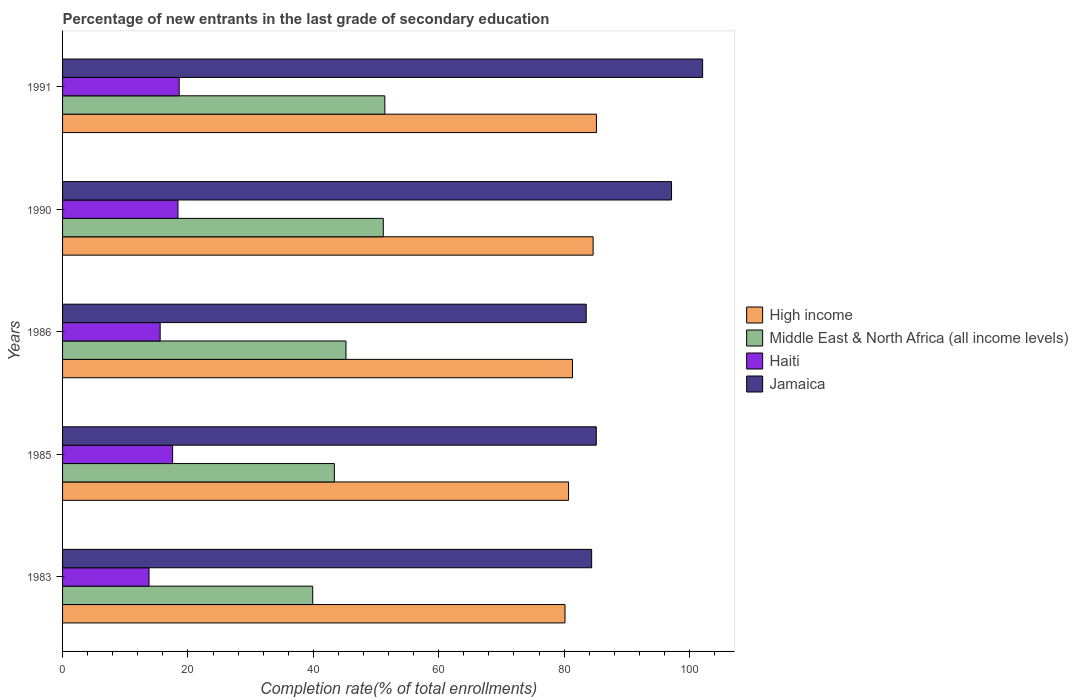How many different coloured bars are there?
Provide a succinct answer. 4. How many groups of bars are there?
Provide a short and direct response. 5. Are the number of bars on each tick of the Y-axis equal?
Keep it short and to the point. Yes. How many bars are there on the 5th tick from the top?
Provide a succinct answer. 4. How many bars are there on the 4th tick from the bottom?
Provide a succinct answer. 4. What is the label of the 4th group of bars from the top?
Keep it short and to the point. 1985. What is the percentage of new entrants in Jamaica in 1985?
Offer a very short reply. 85.13. Across all years, what is the maximum percentage of new entrants in Haiti?
Provide a succinct answer. 18.6. Across all years, what is the minimum percentage of new entrants in Jamaica?
Provide a succinct answer. 83.53. In which year was the percentage of new entrants in High income minimum?
Provide a succinct answer. 1983. What is the total percentage of new entrants in High income in the graph?
Provide a succinct answer. 411.98. What is the difference between the percentage of new entrants in Jamaica in 1985 and that in 1991?
Your answer should be compact. -16.96. What is the difference between the percentage of new entrants in Jamaica in 1985 and the percentage of new entrants in Middle East & North Africa (all income levels) in 1986?
Offer a terse response. 39.93. What is the average percentage of new entrants in High income per year?
Give a very brief answer. 82.4. In the year 1991, what is the difference between the percentage of new entrants in High income and percentage of new entrants in Jamaica?
Give a very brief answer. -16.94. What is the ratio of the percentage of new entrants in Jamaica in 1986 to that in 1991?
Make the answer very short. 0.82. Is the percentage of new entrants in Middle East & North Africa (all income levels) in 1986 less than that in 1990?
Offer a terse response. Yes. Is the difference between the percentage of new entrants in High income in 1990 and 1991 greater than the difference between the percentage of new entrants in Jamaica in 1990 and 1991?
Your response must be concise. Yes. What is the difference between the highest and the second highest percentage of new entrants in Jamaica?
Keep it short and to the point. 4.96. What is the difference between the highest and the lowest percentage of new entrants in Jamaica?
Give a very brief answer. 18.57. Is the sum of the percentage of new entrants in High income in 1985 and 1991 greater than the maximum percentage of new entrants in Middle East & North Africa (all income levels) across all years?
Your answer should be compact. Yes. Is it the case that in every year, the sum of the percentage of new entrants in Middle East & North Africa (all income levels) and percentage of new entrants in Haiti is greater than the sum of percentage of new entrants in High income and percentage of new entrants in Jamaica?
Your response must be concise. No. What does the 3rd bar from the top in 1986 represents?
Make the answer very short. Middle East & North Africa (all income levels). What does the 3rd bar from the bottom in 1990 represents?
Make the answer very short. Haiti. How many bars are there?
Your response must be concise. 20. How many years are there in the graph?
Keep it short and to the point. 5. What is the difference between two consecutive major ticks on the X-axis?
Make the answer very short. 20. Are the values on the major ticks of X-axis written in scientific E-notation?
Make the answer very short. No. How many legend labels are there?
Your answer should be compact. 4. How are the legend labels stacked?
Make the answer very short. Vertical. What is the title of the graph?
Keep it short and to the point. Percentage of new entrants in the last grade of secondary education. Does "Andorra" appear as one of the legend labels in the graph?
Make the answer very short. No. What is the label or title of the X-axis?
Your answer should be compact. Completion rate(% of total enrollments). What is the label or title of the Y-axis?
Provide a short and direct response. Years. What is the Completion rate(% of total enrollments) of High income in 1983?
Provide a succinct answer. 80.15. What is the Completion rate(% of total enrollments) of Middle East & North Africa (all income levels) in 1983?
Offer a very short reply. 39.9. What is the Completion rate(% of total enrollments) in Haiti in 1983?
Keep it short and to the point. 13.79. What is the Completion rate(% of total enrollments) in Jamaica in 1983?
Provide a succinct answer. 84.4. What is the Completion rate(% of total enrollments) in High income in 1985?
Ensure brevity in your answer.  80.71. What is the Completion rate(% of total enrollments) in Middle East & North Africa (all income levels) in 1985?
Provide a succinct answer. 43.35. What is the Completion rate(% of total enrollments) of Haiti in 1985?
Your answer should be very brief. 17.55. What is the Completion rate(% of total enrollments) in Jamaica in 1985?
Your answer should be compact. 85.13. What is the Completion rate(% of total enrollments) of High income in 1986?
Provide a succinct answer. 81.34. What is the Completion rate(% of total enrollments) of Middle East & North Africa (all income levels) in 1986?
Offer a very short reply. 45.21. What is the Completion rate(% of total enrollments) of Haiti in 1986?
Give a very brief answer. 15.57. What is the Completion rate(% of total enrollments) in Jamaica in 1986?
Your answer should be compact. 83.53. What is the Completion rate(% of total enrollments) in High income in 1990?
Make the answer very short. 84.63. What is the Completion rate(% of total enrollments) of Middle East & North Africa (all income levels) in 1990?
Keep it short and to the point. 51.16. What is the Completion rate(% of total enrollments) in Haiti in 1990?
Your response must be concise. 18.41. What is the Completion rate(% of total enrollments) of Jamaica in 1990?
Give a very brief answer. 97.14. What is the Completion rate(% of total enrollments) of High income in 1991?
Your answer should be very brief. 85.16. What is the Completion rate(% of total enrollments) in Middle East & North Africa (all income levels) in 1991?
Provide a succinct answer. 51.41. What is the Completion rate(% of total enrollments) in Haiti in 1991?
Your answer should be compact. 18.6. What is the Completion rate(% of total enrollments) of Jamaica in 1991?
Make the answer very short. 102.1. Across all years, what is the maximum Completion rate(% of total enrollments) of High income?
Give a very brief answer. 85.16. Across all years, what is the maximum Completion rate(% of total enrollments) of Middle East & North Africa (all income levels)?
Your response must be concise. 51.41. Across all years, what is the maximum Completion rate(% of total enrollments) of Haiti?
Your response must be concise. 18.6. Across all years, what is the maximum Completion rate(% of total enrollments) of Jamaica?
Provide a short and direct response. 102.1. Across all years, what is the minimum Completion rate(% of total enrollments) in High income?
Make the answer very short. 80.15. Across all years, what is the minimum Completion rate(% of total enrollments) of Middle East & North Africa (all income levels)?
Offer a terse response. 39.9. Across all years, what is the minimum Completion rate(% of total enrollments) in Haiti?
Your answer should be very brief. 13.79. Across all years, what is the minimum Completion rate(% of total enrollments) of Jamaica?
Your answer should be very brief. 83.53. What is the total Completion rate(% of total enrollments) in High income in the graph?
Your response must be concise. 411.98. What is the total Completion rate(% of total enrollments) in Middle East & North Africa (all income levels) in the graph?
Provide a succinct answer. 231.02. What is the total Completion rate(% of total enrollments) of Haiti in the graph?
Give a very brief answer. 83.92. What is the total Completion rate(% of total enrollments) of Jamaica in the graph?
Your answer should be compact. 452.29. What is the difference between the Completion rate(% of total enrollments) of High income in 1983 and that in 1985?
Provide a succinct answer. -0.56. What is the difference between the Completion rate(% of total enrollments) of Middle East & North Africa (all income levels) in 1983 and that in 1985?
Ensure brevity in your answer.  -3.45. What is the difference between the Completion rate(% of total enrollments) of Haiti in 1983 and that in 1985?
Make the answer very short. -3.76. What is the difference between the Completion rate(% of total enrollments) in Jamaica in 1983 and that in 1985?
Keep it short and to the point. -0.74. What is the difference between the Completion rate(% of total enrollments) of High income in 1983 and that in 1986?
Provide a succinct answer. -1.19. What is the difference between the Completion rate(% of total enrollments) in Middle East & North Africa (all income levels) in 1983 and that in 1986?
Offer a terse response. -5.31. What is the difference between the Completion rate(% of total enrollments) in Haiti in 1983 and that in 1986?
Ensure brevity in your answer.  -1.78. What is the difference between the Completion rate(% of total enrollments) in Jamaica in 1983 and that in 1986?
Offer a terse response. 0.87. What is the difference between the Completion rate(% of total enrollments) of High income in 1983 and that in 1990?
Your answer should be very brief. -4.48. What is the difference between the Completion rate(% of total enrollments) in Middle East & North Africa (all income levels) in 1983 and that in 1990?
Your response must be concise. -11.25. What is the difference between the Completion rate(% of total enrollments) of Haiti in 1983 and that in 1990?
Make the answer very short. -4.62. What is the difference between the Completion rate(% of total enrollments) of Jamaica in 1983 and that in 1990?
Keep it short and to the point. -12.74. What is the difference between the Completion rate(% of total enrollments) of High income in 1983 and that in 1991?
Keep it short and to the point. -5.01. What is the difference between the Completion rate(% of total enrollments) of Middle East & North Africa (all income levels) in 1983 and that in 1991?
Your answer should be very brief. -11.5. What is the difference between the Completion rate(% of total enrollments) in Haiti in 1983 and that in 1991?
Keep it short and to the point. -4.81. What is the difference between the Completion rate(% of total enrollments) in Jamaica in 1983 and that in 1991?
Your response must be concise. -17.7. What is the difference between the Completion rate(% of total enrollments) in High income in 1985 and that in 1986?
Your response must be concise. -0.63. What is the difference between the Completion rate(% of total enrollments) in Middle East & North Africa (all income levels) in 1985 and that in 1986?
Make the answer very short. -1.86. What is the difference between the Completion rate(% of total enrollments) of Haiti in 1985 and that in 1986?
Ensure brevity in your answer.  1.98. What is the difference between the Completion rate(% of total enrollments) of Jamaica in 1985 and that in 1986?
Give a very brief answer. 1.61. What is the difference between the Completion rate(% of total enrollments) in High income in 1985 and that in 1990?
Offer a terse response. -3.92. What is the difference between the Completion rate(% of total enrollments) of Middle East & North Africa (all income levels) in 1985 and that in 1990?
Provide a short and direct response. -7.81. What is the difference between the Completion rate(% of total enrollments) in Haiti in 1985 and that in 1990?
Give a very brief answer. -0.86. What is the difference between the Completion rate(% of total enrollments) in Jamaica in 1985 and that in 1990?
Provide a succinct answer. -12. What is the difference between the Completion rate(% of total enrollments) of High income in 1985 and that in 1991?
Your response must be concise. -4.44. What is the difference between the Completion rate(% of total enrollments) of Middle East & North Africa (all income levels) in 1985 and that in 1991?
Offer a very short reply. -8.06. What is the difference between the Completion rate(% of total enrollments) of Haiti in 1985 and that in 1991?
Provide a short and direct response. -1.05. What is the difference between the Completion rate(% of total enrollments) in Jamaica in 1985 and that in 1991?
Make the answer very short. -16.96. What is the difference between the Completion rate(% of total enrollments) of High income in 1986 and that in 1990?
Offer a very short reply. -3.29. What is the difference between the Completion rate(% of total enrollments) in Middle East & North Africa (all income levels) in 1986 and that in 1990?
Your response must be concise. -5.95. What is the difference between the Completion rate(% of total enrollments) in Haiti in 1986 and that in 1990?
Your response must be concise. -2.84. What is the difference between the Completion rate(% of total enrollments) in Jamaica in 1986 and that in 1990?
Provide a succinct answer. -13.61. What is the difference between the Completion rate(% of total enrollments) of High income in 1986 and that in 1991?
Your answer should be compact. -3.81. What is the difference between the Completion rate(% of total enrollments) in Middle East & North Africa (all income levels) in 1986 and that in 1991?
Provide a short and direct response. -6.2. What is the difference between the Completion rate(% of total enrollments) of Haiti in 1986 and that in 1991?
Your answer should be very brief. -3.03. What is the difference between the Completion rate(% of total enrollments) in Jamaica in 1986 and that in 1991?
Ensure brevity in your answer.  -18.57. What is the difference between the Completion rate(% of total enrollments) in High income in 1990 and that in 1991?
Ensure brevity in your answer.  -0.53. What is the difference between the Completion rate(% of total enrollments) of Middle East & North Africa (all income levels) in 1990 and that in 1991?
Your answer should be compact. -0.25. What is the difference between the Completion rate(% of total enrollments) in Haiti in 1990 and that in 1991?
Provide a succinct answer. -0.19. What is the difference between the Completion rate(% of total enrollments) in Jamaica in 1990 and that in 1991?
Your response must be concise. -4.96. What is the difference between the Completion rate(% of total enrollments) of High income in 1983 and the Completion rate(% of total enrollments) of Middle East & North Africa (all income levels) in 1985?
Provide a short and direct response. 36.79. What is the difference between the Completion rate(% of total enrollments) in High income in 1983 and the Completion rate(% of total enrollments) in Haiti in 1985?
Offer a very short reply. 62.59. What is the difference between the Completion rate(% of total enrollments) in High income in 1983 and the Completion rate(% of total enrollments) in Jamaica in 1985?
Keep it short and to the point. -4.99. What is the difference between the Completion rate(% of total enrollments) in Middle East & North Africa (all income levels) in 1983 and the Completion rate(% of total enrollments) in Haiti in 1985?
Your answer should be compact. 22.35. What is the difference between the Completion rate(% of total enrollments) of Middle East & North Africa (all income levels) in 1983 and the Completion rate(% of total enrollments) of Jamaica in 1985?
Offer a terse response. -45.23. What is the difference between the Completion rate(% of total enrollments) of Haiti in 1983 and the Completion rate(% of total enrollments) of Jamaica in 1985?
Ensure brevity in your answer.  -71.34. What is the difference between the Completion rate(% of total enrollments) of High income in 1983 and the Completion rate(% of total enrollments) of Middle East & North Africa (all income levels) in 1986?
Your answer should be very brief. 34.94. What is the difference between the Completion rate(% of total enrollments) of High income in 1983 and the Completion rate(% of total enrollments) of Haiti in 1986?
Provide a succinct answer. 64.58. What is the difference between the Completion rate(% of total enrollments) of High income in 1983 and the Completion rate(% of total enrollments) of Jamaica in 1986?
Provide a succinct answer. -3.38. What is the difference between the Completion rate(% of total enrollments) of Middle East & North Africa (all income levels) in 1983 and the Completion rate(% of total enrollments) of Haiti in 1986?
Provide a succinct answer. 24.33. What is the difference between the Completion rate(% of total enrollments) in Middle East & North Africa (all income levels) in 1983 and the Completion rate(% of total enrollments) in Jamaica in 1986?
Offer a terse response. -43.63. What is the difference between the Completion rate(% of total enrollments) in Haiti in 1983 and the Completion rate(% of total enrollments) in Jamaica in 1986?
Make the answer very short. -69.74. What is the difference between the Completion rate(% of total enrollments) in High income in 1983 and the Completion rate(% of total enrollments) in Middle East & North Africa (all income levels) in 1990?
Your response must be concise. 28.99. What is the difference between the Completion rate(% of total enrollments) in High income in 1983 and the Completion rate(% of total enrollments) in Haiti in 1990?
Offer a terse response. 61.74. What is the difference between the Completion rate(% of total enrollments) of High income in 1983 and the Completion rate(% of total enrollments) of Jamaica in 1990?
Your answer should be compact. -16.99. What is the difference between the Completion rate(% of total enrollments) in Middle East & North Africa (all income levels) in 1983 and the Completion rate(% of total enrollments) in Haiti in 1990?
Ensure brevity in your answer.  21.49. What is the difference between the Completion rate(% of total enrollments) of Middle East & North Africa (all income levels) in 1983 and the Completion rate(% of total enrollments) of Jamaica in 1990?
Ensure brevity in your answer.  -57.24. What is the difference between the Completion rate(% of total enrollments) of Haiti in 1983 and the Completion rate(% of total enrollments) of Jamaica in 1990?
Provide a short and direct response. -83.35. What is the difference between the Completion rate(% of total enrollments) in High income in 1983 and the Completion rate(% of total enrollments) in Middle East & North Africa (all income levels) in 1991?
Ensure brevity in your answer.  28.74. What is the difference between the Completion rate(% of total enrollments) of High income in 1983 and the Completion rate(% of total enrollments) of Haiti in 1991?
Provide a succinct answer. 61.55. What is the difference between the Completion rate(% of total enrollments) of High income in 1983 and the Completion rate(% of total enrollments) of Jamaica in 1991?
Keep it short and to the point. -21.95. What is the difference between the Completion rate(% of total enrollments) of Middle East & North Africa (all income levels) in 1983 and the Completion rate(% of total enrollments) of Haiti in 1991?
Provide a succinct answer. 21.3. What is the difference between the Completion rate(% of total enrollments) in Middle East & North Africa (all income levels) in 1983 and the Completion rate(% of total enrollments) in Jamaica in 1991?
Offer a terse response. -62.19. What is the difference between the Completion rate(% of total enrollments) of Haiti in 1983 and the Completion rate(% of total enrollments) of Jamaica in 1991?
Make the answer very short. -88.3. What is the difference between the Completion rate(% of total enrollments) in High income in 1985 and the Completion rate(% of total enrollments) in Middle East & North Africa (all income levels) in 1986?
Your answer should be very brief. 35.5. What is the difference between the Completion rate(% of total enrollments) in High income in 1985 and the Completion rate(% of total enrollments) in Haiti in 1986?
Your answer should be very brief. 65.14. What is the difference between the Completion rate(% of total enrollments) of High income in 1985 and the Completion rate(% of total enrollments) of Jamaica in 1986?
Keep it short and to the point. -2.82. What is the difference between the Completion rate(% of total enrollments) in Middle East & North Africa (all income levels) in 1985 and the Completion rate(% of total enrollments) in Haiti in 1986?
Ensure brevity in your answer.  27.78. What is the difference between the Completion rate(% of total enrollments) in Middle East & North Africa (all income levels) in 1985 and the Completion rate(% of total enrollments) in Jamaica in 1986?
Keep it short and to the point. -40.18. What is the difference between the Completion rate(% of total enrollments) in Haiti in 1985 and the Completion rate(% of total enrollments) in Jamaica in 1986?
Make the answer very short. -65.98. What is the difference between the Completion rate(% of total enrollments) in High income in 1985 and the Completion rate(% of total enrollments) in Middle East & North Africa (all income levels) in 1990?
Your answer should be very brief. 29.55. What is the difference between the Completion rate(% of total enrollments) in High income in 1985 and the Completion rate(% of total enrollments) in Haiti in 1990?
Provide a succinct answer. 62.3. What is the difference between the Completion rate(% of total enrollments) of High income in 1985 and the Completion rate(% of total enrollments) of Jamaica in 1990?
Give a very brief answer. -16.43. What is the difference between the Completion rate(% of total enrollments) in Middle East & North Africa (all income levels) in 1985 and the Completion rate(% of total enrollments) in Haiti in 1990?
Keep it short and to the point. 24.94. What is the difference between the Completion rate(% of total enrollments) in Middle East & North Africa (all income levels) in 1985 and the Completion rate(% of total enrollments) in Jamaica in 1990?
Offer a terse response. -53.79. What is the difference between the Completion rate(% of total enrollments) of Haiti in 1985 and the Completion rate(% of total enrollments) of Jamaica in 1990?
Make the answer very short. -79.59. What is the difference between the Completion rate(% of total enrollments) of High income in 1985 and the Completion rate(% of total enrollments) of Middle East & North Africa (all income levels) in 1991?
Your answer should be compact. 29.3. What is the difference between the Completion rate(% of total enrollments) of High income in 1985 and the Completion rate(% of total enrollments) of Haiti in 1991?
Give a very brief answer. 62.11. What is the difference between the Completion rate(% of total enrollments) of High income in 1985 and the Completion rate(% of total enrollments) of Jamaica in 1991?
Offer a very short reply. -21.39. What is the difference between the Completion rate(% of total enrollments) of Middle East & North Africa (all income levels) in 1985 and the Completion rate(% of total enrollments) of Haiti in 1991?
Offer a very short reply. 24.75. What is the difference between the Completion rate(% of total enrollments) of Middle East & North Africa (all income levels) in 1985 and the Completion rate(% of total enrollments) of Jamaica in 1991?
Your answer should be very brief. -58.75. What is the difference between the Completion rate(% of total enrollments) in Haiti in 1985 and the Completion rate(% of total enrollments) in Jamaica in 1991?
Your response must be concise. -84.54. What is the difference between the Completion rate(% of total enrollments) of High income in 1986 and the Completion rate(% of total enrollments) of Middle East & North Africa (all income levels) in 1990?
Your response must be concise. 30.18. What is the difference between the Completion rate(% of total enrollments) in High income in 1986 and the Completion rate(% of total enrollments) in Haiti in 1990?
Make the answer very short. 62.93. What is the difference between the Completion rate(% of total enrollments) in High income in 1986 and the Completion rate(% of total enrollments) in Jamaica in 1990?
Provide a succinct answer. -15.8. What is the difference between the Completion rate(% of total enrollments) in Middle East & North Africa (all income levels) in 1986 and the Completion rate(% of total enrollments) in Haiti in 1990?
Your answer should be very brief. 26.8. What is the difference between the Completion rate(% of total enrollments) of Middle East & North Africa (all income levels) in 1986 and the Completion rate(% of total enrollments) of Jamaica in 1990?
Give a very brief answer. -51.93. What is the difference between the Completion rate(% of total enrollments) in Haiti in 1986 and the Completion rate(% of total enrollments) in Jamaica in 1990?
Provide a short and direct response. -81.57. What is the difference between the Completion rate(% of total enrollments) in High income in 1986 and the Completion rate(% of total enrollments) in Middle East & North Africa (all income levels) in 1991?
Provide a short and direct response. 29.93. What is the difference between the Completion rate(% of total enrollments) in High income in 1986 and the Completion rate(% of total enrollments) in Haiti in 1991?
Provide a short and direct response. 62.74. What is the difference between the Completion rate(% of total enrollments) in High income in 1986 and the Completion rate(% of total enrollments) in Jamaica in 1991?
Offer a terse response. -20.76. What is the difference between the Completion rate(% of total enrollments) of Middle East & North Africa (all income levels) in 1986 and the Completion rate(% of total enrollments) of Haiti in 1991?
Your answer should be compact. 26.61. What is the difference between the Completion rate(% of total enrollments) of Middle East & North Africa (all income levels) in 1986 and the Completion rate(% of total enrollments) of Jamaica in 1991?
Make the answer very short. -56.89. What is the difference between the Completion rate(% of total enrollments) in Haiti in 1986 and the Completion rate(% of total enrollments) in Jamaica in 1991?
Your answer should be very brief. -86.53. What is the difference between the Completion rate(% of total enrollments) in High income in 1990 and the Completion rate(% of total enrollments) in Middle East & North Africa (all income levels) in 1991?
Your response must be concise. 33.22. What is the difference between the Completion rate(% of total enrollments) in High income in 1990 and the Completion rate(% of total enrollments) in Haiti in 1991?
Offer a terse response. 66.03. What is the difference between the Completion rate(% of total enrollments) in High income in 1990 and the Completion rate(% of total enrollments) in Jamaica in 1991?
Offer a very short reply. -17.47. What is the difference between the Completion rate(% of total enrollments) in Middle East & North Africa (all income levels) in 1990 and the Completion rate(% of total enrollments) in Haiti in 1991?
Give a very brief answer. 32.56. What is the difference between the Completion rate(% of total enrollments) of Middle East & North Africa (all income levels) in 1990 and the Completion rate(% of total enrollments) of Jamaica in 1991?
Offer a very short reply. -50.94. What is the difference between the Completion rate(% of total enrollments) of Haiti in 1990 and the Completion rate(% of total enrollments) of Jamaica in 1991?
Keep it short and to the point. -83.69. What is the average Completion rate(% of total enrollments) in High income per year?
Ensure brevity in your answer.  82.4. What is the average Completion rate(% of total enrollments) in Middle East & North Africa (all income levels) per year?
Keep it short and to the point. 46.2. What is the average Completion rate(% of total enrollments) of Haiti per year?
Offer a very short reply. 16.78. What is the average Completion rate(% of total enrollments) in Jamaica per year?
Offer a terse response. 90.46. In the year 1983, what is the difference between the Completion rate(% of total enrollments) of High income and Completion rate(% of total enrollments) of Middle East & North Africa (all income levels)?
Your answer should be compact. 40.24. In the year 1983, what is the difference between the Completion rate(% of total enrollments) in High income and Completion rate(% of total enrollments) in Haiti?
Ensure brevity in your answer.  66.35. In the year 1983, what is the difference between the Completion rate(% of total enrollments) of High income and Completion rate(% of total enrollments) of Jamaica?
Give a very brief answer. -4.25. In the year 1983, what is the difference between the Completion rate(% of total enrollments) in Middle East & North Africa (all income levels) and Completion rate(% of total enrollments) in Haiti?
Make the answer very short. 26.11. In the year 1983, what is the difference between the Completion rate(% of total enrollments) of Middle East & North Africa (all income levels) and Completion rate(% of total enrollments) of Jamaica?
Ensure brevity in your answer.  -44.49. In the year 1983, what is the difference between the Completion rate(% of total enrollments) in Haiti and Completion rate(% of total enrollments) in Jamaica?
Your response must be concise. -70.6. In the year 1985, what is the difference between the Completion rate(% of total enrollments) in High income and Completion rate(% of total enrollments) in Middle East & North Africa (all income levels)?
Keep it short and to the point. 37.36. In the year 1985, what is the difference between the Completion rate(% of total enrollments) of High income and Completion rate(% of total enrollments) of Haiti?
Keep it short and to the point. 63.16. In the year 1985, what is the difference between the Completion rate(% of total enrollments) of High income and Completion rate(% of total enrollments) of Jamaica?
Your answer should be very brief. -4.42. In the year 1985, what is the difference between the Completion rate(% of total enrollments) in Middle East & North Africa (all income levels) and Completion rate(% of total enrollments) in Haiti?
Offer a terse response. 25.8. In the year 1985, what is the difference between the Completion rate(% of total enrollments) in Middle East & North Africa (all income levels) and Completion rate(% of total enrollments) in Jamaica?
Offer a terse response. -41.78. In the year 1985, what is the difference between the Completion rate(% of total enrollments) of Haiti and Completion rate(% of total enrollments) of Jamaica?
Keep it short and to the point. -67.58. In the year 1986, what is the difference between the Completion rate(% of total enrollments) of High income and Completion rate(% of total enrollments) of Middle East & North Africa (all income levels)?
Keep it short and to the point. 36.13. In the year 1986, what is the difference between the Completion rate(% of total enrollments) in High income and Completion rate(% of total enrollments) in Haiti?
Offer a very short reply. 65.77. In the year 1986, what is the difference between the Completion rate(% of total enrollments) in High income and Completion rate(% of total enrollments) in Jamaica?
Your answer should be very brief. -2.19. In the year 1986, what is the difference between the Completion rate(% of total enrollments) in Middle East & North Africa (all income levels) and Completion rate(% of total enrollments) in Haiti?
Ensure brevity in your answer.  29.64. In the year 1986, what is the difference between the Completion rate(% of total enrollments) in Middle East & North Africa (all income levels) and Completion rate(% of total enrollments) in Jamaica?
Provide a short and direct response. -38.32. In the year 1986, what is the difference between the Completion rate(% of total enrollments) of Haiti and Completion rate(% of total enrollments) of Jamaica?
Provide a succinct answer. -67.96. In the year 1990, what is the difference between the Completion rate(% of total enrollments) of High income and Completion rate(% of total enrollments) of Middle East & North Africa (all income levels)?
Offer a very short reply. 33.47. In the year 1990, what is the difference between the Completion rate(% of total enrollments) of High income and Completion rate(% of total enrollments) of Haiti?
Give a very brief answer. 66.22. In the year 1990, what is the difference between the Completion rate(% of total enrollments) in High income and Completion rate(% of total enrollments) in Jamaica?
Provide a succinct answer. -12.51. In the year 1990, what is the difference between the Completion rate(% of total enrollments) of Middle East & North Africa (all income levels) and Completion rate(% of total enrollments) of Haiti?
Make the answer very short. 32.75. In the year 1990, what is the difference between the Completion rate(% of total enrollments) of Middle East & North Africa (all income levels) and Completion rate(% of total enrollments) of Jamaica?
Provide a succinct answer. -45.98. In the year 1990, what is the difference between the Completion rate(% of total enrollments) in Haiti and Completion rate(% of total enrollments) in Jamaica?
Offer a terse response. -78.73. In the year 1991, what is the difference between the Completion rate(% of total enrollments) of High income and Completion rate(% of total enrollments) of Middle East & North Africa (all income levels)?
Make the answer very short. 33.75. In the year 1991, what is the difference between the Completion rate(% of total enrollments) in High income and Completion rate(% of total enrollments) in Haiti?
Offer a very short reply. 66.55. In the year 1991, what is the difference between the Completion rate(% of total enrollments) in High income and Completion rate(% of total enrollments) in Jamaica?
Give a very brief answer. -16.94. In the year 1991, what is the difference between the Completion rate(% of total enrollments) of Middle East & North Africa (all income levels) and Completion rate(% of total enrollments) of Haiti?
Give a very brief answer. 32.81. In the year 1991, what is the difference between the Completion rate(% of total enrollments) in Middle East & North Africa (all income levels) and Completion rate(% of total enrollments) in Jamaica?
Offer a terse response. -50.69. In the year 1991, what is the difference between the Completion rate(% of total enrollments) of Haiti and Completion rate(% of total enrollments) of Jamaica?
Keep it short and to the point. -83.5. What is the ratio of the Completion rate(% of total enrollments) of Middle East & North Africa (all income levels) in 1983 to that in 1985?
Your answer should be very brief. 0.92. What is the ratio of the Completion rate(% of total enrollments) in Haiti in 1983 to that in 1985?
Keep it short and to the point. 0.79. What is the ratio of the Completion rate(% of total enrollments) in Jamaica in 1983 to that in 1985?
Provide a short and direct response. 0.99. What is the ratio of the Completion rate(% of total enrollments) of High income in 1983 to that in 1986?
Ensure brevity in your answer.  0.99. What is the ratio of the Completion rate(% of total enrollments) of Middle East & North Africa (all income levels) in 1983 to that in 1986?
Provide a succinct answer. 0.88. What is the ratio of the Completion rate(% of total enrollments) in Haiti in 1983 to that in 1986?
Give a very brief answer. 0.89. What is the ratio of the Completion rate(% of total enrollments) in Jamaica in 1983 to that in 1986?
Your answer should be very brief. 1.01. What is the ratio of the Completion rate(% of total enrollments) in High income in 1983 to that in 1990?
Offer a very short reply. 0.95. What is the ratio of the Completion rate(% of total enrollments) in Middle East & North Africa (all income levels) in 1983 to that in 1990?
Your response must be concise. 0.78. What is the ratio of the Completion rate(% of total enrollments) of Haiti in 1983 to that in 1990?
Make the answer very short. 0.75. What is the ratio of the Completion rate(% of total enrollments) of Jamaica in 1983 to that in 1990?
Offer a very short reply. 0.87. What is the ratio of the Completion rate(% of total enrollments) in High income in 1983 to that in 1991?
Provide a succinct answer. 0.94. What is the ratio of the Completion rate(% of total enrollments) of Middle East & North Africa (all income levels) in 1983 to that in 1991?
Offer a very short reply. 0.78. What is the ratio of the Completion rate(% of total enrollments) of Haiti in 1983 to that in 1991?
Make the answer very short. 0.74. What is the ratio of the Completion rate(% of total enrollments) in Jamaica in 1983 to that in 1991?
Give a very brief answer. 0.83. What is the ratio of the Completion rate(% of total enrollments) of Middle East & North Africa (all income levels) in 1985 to that in 1986?
Offer a terse response. 0.96. What is the ratio of the Completion rate(% of total enrollments) in Haiti in 1985 to that in 1986?
Your response must be concise. 1.13. What is the ratio of the Completion rate(% of total enrollments) of Jamaica in 1985 to that in 1986?
Make the answer very short. 1.02. What is the ratio of the Completion rate(% of total enrollments) in High income in 1985 to that in 1990?
Make the answer very short. 0.95. What is the ratio of the Completion rate(% of total enrollments) of Middle East & North Africa (all income levels) in 1985 to that in 1990?
Provide a succinct answer. 0.85. What is the ratio of the Completion rate(% of total enrollments) of Haiti in 1985 to that in 1990?
Your response must be concise. 0.95. What is the ratio of the Completion rate(% of total enrollments) of Jamaica in 1985 to that in 1990?
Offer a terse response. 0.88. What is the ratio of the Completion rate(% of total enrollments) in High income in 1985 to that in 1991?
Your answer should be compact. 0.95. What is the ratio of the Completion rate(% of total enrollments) of Middle East & North Africa (all income levels) in 1985 to that in 1991?
Your response must be concise. 0.84. What is the ratio of the Completion rate(% of total enrollments) in Haiti in 1985 to that in 1991?
Provide a succinct answer. 0.94. What is the ratio of the Completion rate(% of total enrollments) in Jamaica in 1985 to that in 1991?
Provide a short and direct response. 0.83. What is the ratio of the Completion rate(% of total enrollments) in High income in 1986 to that in 1990?
Give a very brief answer. 0.96. What is the ratio of the Completion rate(% of total enrollments) in Middle East & North Africa (all income levels) in 1986 to that in 1990?
Your answer should be very brief. 0.88. What is the ratio of the Completion rate(% of total enrollments) in Haiti in 1986 to that in 1990?
Offer a very short reply. 0.85. What is the ratio of the Completion rate(% of total enrollments) in Jamaica in 1986 to that in 1990?
Keep it short and to the point. 0.86. What is the ratio of the Completion rate(% of total enrollments) in High income in 1986 to that in 1991?
Your answer should be very brief. 0.96. What is the ratio of the Completion rate(% of total enrollments) of Middle East & North Africa (all income levels) in 1986 to that in 1991?
Your response must be concise. 0.88. What is the ratio of the Completion rate(% of total enrollments) in Haiti in 1986 to that in 1991?
Your answer should be very brief. 0.84. What is the ratio of the Completion rate(% of total enrollments) of Jamaica in 1986 to that in 1991?
Ensure brevity in your answer.  0.82. What is the ratio of the Completion rate(% of total enrollments) of Haiti in 1990 to that in 1991?
Make the answer very short. 0.99. What is the ratio of the Completion rate(% of total enrollments) of Jamaica in 1990 to that in 1991?
Your response must be concise. 0.95. What is the difference between the highest and the second highest Completion rate(% of total enrollments) of High income?
Keep it short and to the point. 0.53. What is the difference between the highest and the second highest Completion rate(% of total enrollments) of Middle East & North Africa (all income levels)?
Keep it short and to the point. 0.25. What is the difference between the highest and the second highest Completion rate(% of total enrollments) in Haiti?
Offer a very short reply. 0.19. What is the difference between the highest and the second highest Completion rate(% of total enrollments) of Jamaica?
Make the answer very short. 4.96. What is the difference between the highest and the lowest Completion rate(% of total enrollments) in High income?
Your answer should be compact. 5.01. What is the difference between the highest and the lowest Completion rate(% of total enrollments) in Middle East & North Africa (all income levels)?
Give a very brief answer. 11.5. What is the difference between the highest and the lowest Completion rate(% of total enrollments) of Haiti?
Offer a very short reply. 4.81. What is the difference between the highest and the lowest Completion rate(% of total enrollments) of Jamaica?
Make the answer very short. 18.57. 